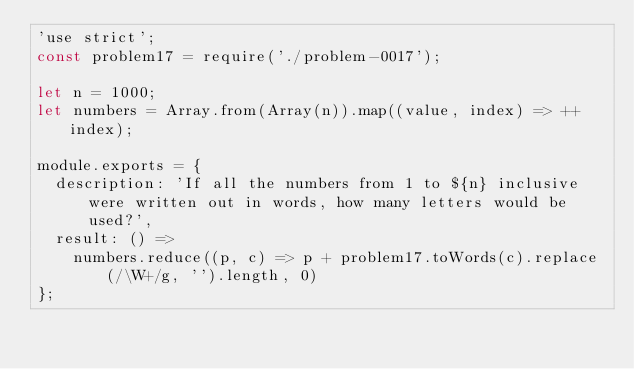Convert code to text. <code><loc_0><loc_0><loc_500><loc_500><_JavaScript_>'use strict';
const problem17 = require('./problem-0017');

let n = 1000;
let numbers = Array.from(Array(n)).map((value, index) => ++index);

module.exports = {
  description: 'If all the numbers from 1 to ${n} inclusive were written out in words, how many letters would be used?',
  result: () =>
    numbers.reduce((p, c) => p + problem17.toWords(c).replace(/\W+/g, '').length, 0)
};
</code> 